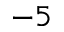<formula> <loc_0><loc_0><loc_500><loc_500>- 5</formula> 